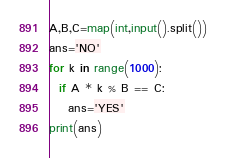Convert code to text. <code><loc_0><loc_0><loc_500><loc_500><_Python_>A,B,C=map(int,input().split())
ans='NO'
for k in range(1000):
  if A * k % B == C:
    ans='YES'
print(ans)</code> 